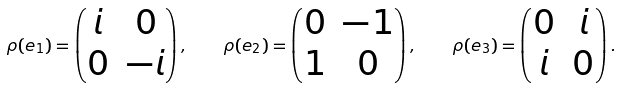Convert formula to latex. <formula><loc_0><loc_0><loc_500><loc_500>\rho ( e _ { 1 } ) = \begin{pmatrix} i & 0 \\ 0 & - i \end{pmatrix} , \quad \rho ( e _ { 2 } ) = \begin{pmatrix} 0 & - 1 \\ 1 & 0 \end{pmatrix} , \quad \rho ( e _ { 3 } ) = \begin{pmatrix} 0 & i \\ i & 0 \end{pmatrix} .</formula> 